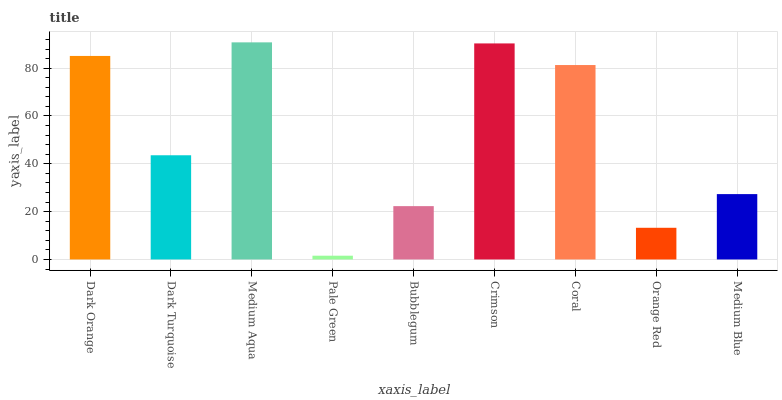Is Pale Green the minimum?
Answer yes or no. Yes. Is Medium Aqua the maximum?
Answer yes or no. Yes. Is Dark Turquoise the minimum?
Answer yes or no. No. Is Dark Turquoise the maximum?
Answer yes or no. No. Is Dark Orange greater than Dark Turquoise?
Answer yes or no. Yes. Is Dark Turquoise less than Dark Orange?
Answer yes or no. Yes. Is Dark Turquoise greater than Dark Orange?
Answer yes or no. No. Is Dark Orange less than Dark Turquoise?
Answer yes or no. No. Is Dark Turquoise the high median?
Answer yes or no. Yes. Is Dark Turquoise the low median?
Answer yes or no. Yes. Is Dark Orange the high median?
Answer yes or no. No. Is Dark Orange the low median?
Answer yes or no. No. 